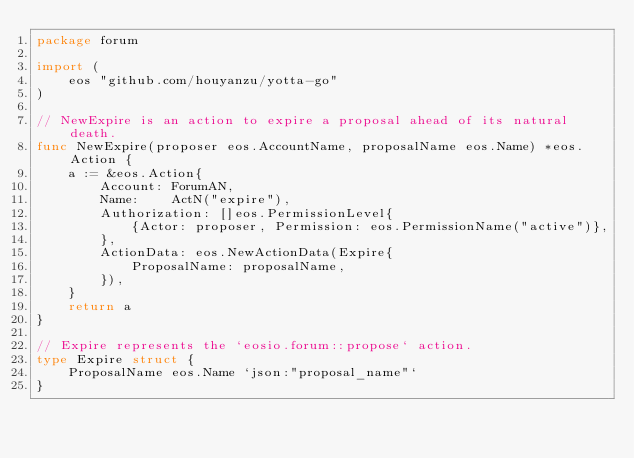Convert code to text. <code><loc_0><loc_0><loc_500><loc_500><_Go_>package forum

import (
	eos "github.com/houyanzu/yotta-go"
)

// NewExpire is an action to expire a proposal ahead of its natural death.
func NewExpire(proposer eos.AccountName, proposalName eos.Name) *eos.Action {
	a := &eos.Action{
		Account: ForumAN,
		Name:    ActN("expire"),
		Authorization: []eos.PermissionLevel{
			{Actor: proposer, Permission: eos.PermissionName("active")},
		},
		ActionData: eos.NewActionData(Expire{
			ProposalName: proposalName,
		}),
	}
	return a
}

// Expire represents the `eosio.forum::propose` action.
type Expire struct {
	ProposalName eos.Name `json:"proposal_name"`
}
</code> 